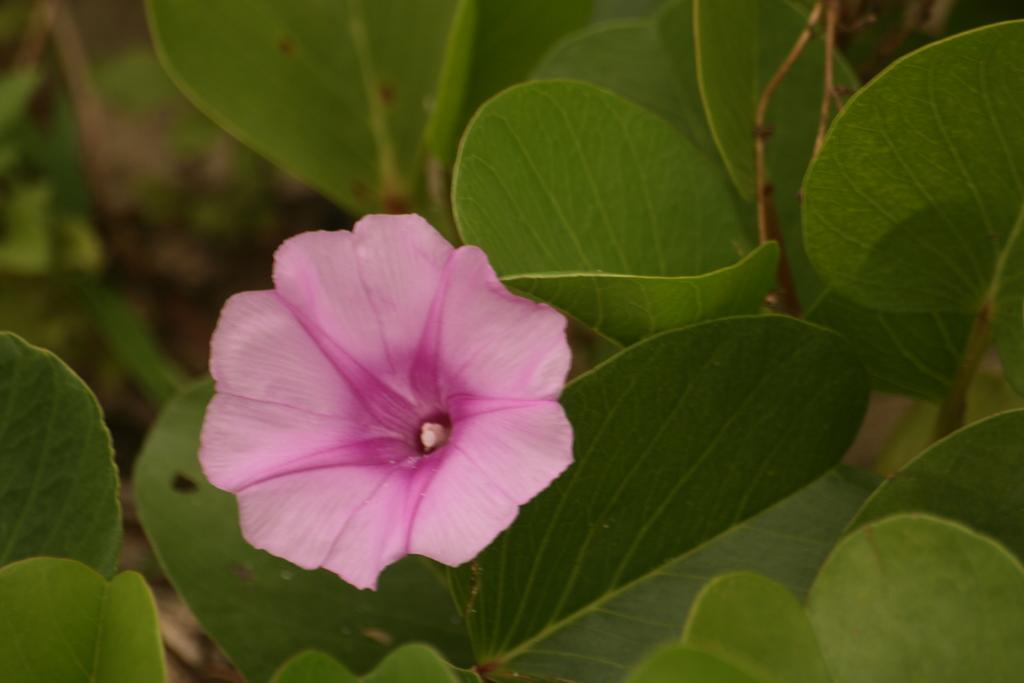What is the main subject of the image? There is a flower in the image. Is the flower part of a larger plant? Yes, the flower is attached to a plant. What else can be seen around the flower? There are leaves visible around the flower. What flavor of ice cream is being served at the hospital in the image? There is no ice cream or hospital present in the image; it features a flower attached to a plant with leaves around it. 